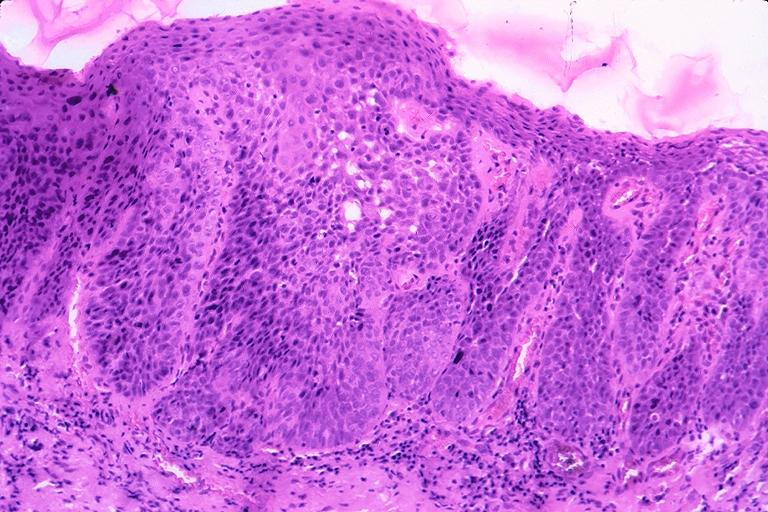where is this?
Answer the question using a single word or phrase. Oral 